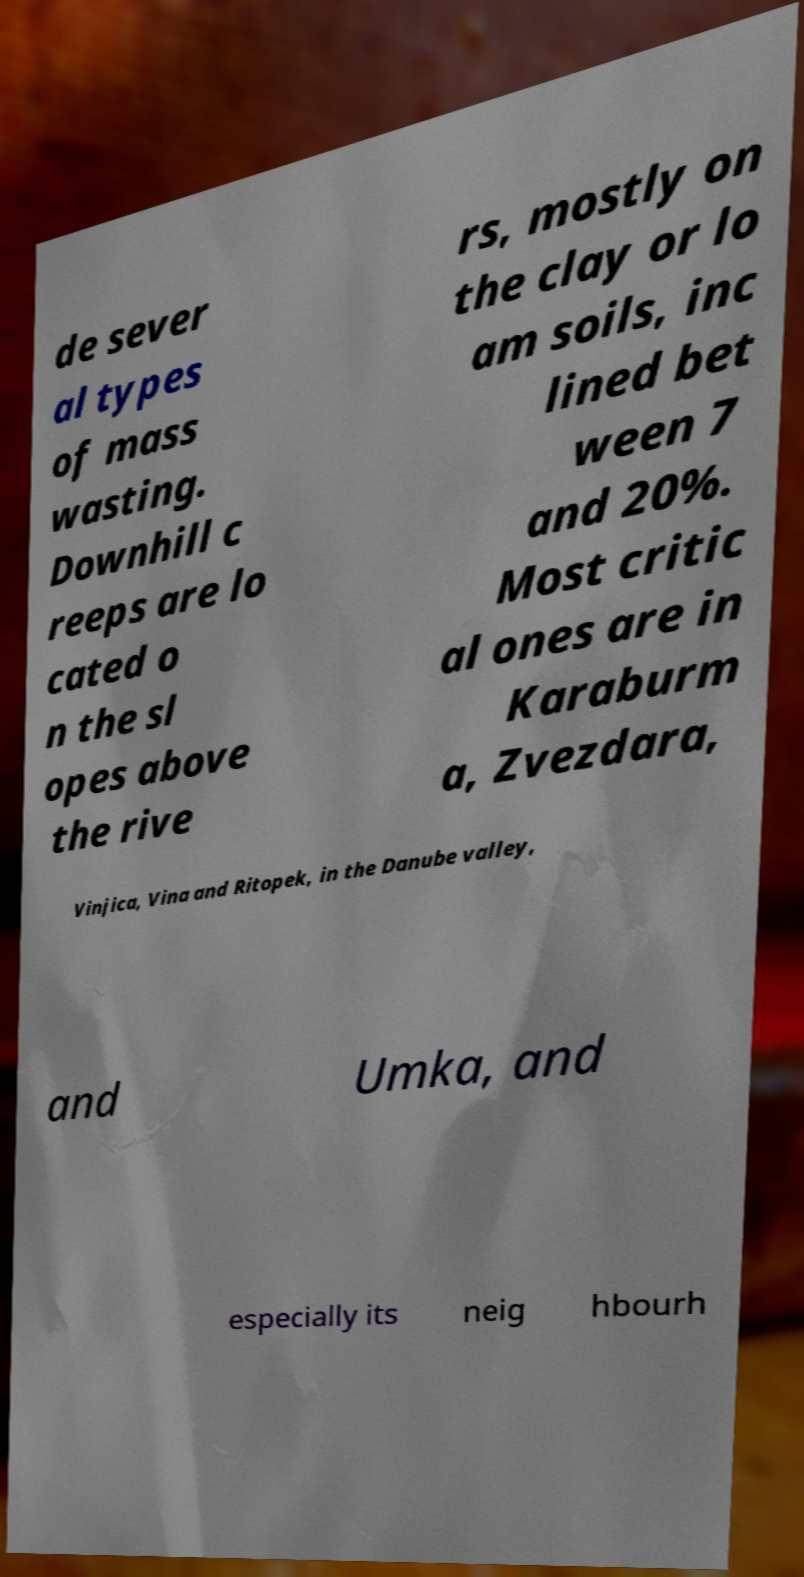Can you accurately transcribe the text from the provided image for me? de sever al types of mass wasting. Downhill c reeps are lo cated o n the sl opes above the rive rs, mostly on the clay or lo am soils, inc lined bet ween 7 and 20%. Most critic al ones are in Karaburm a, Zvezdara, Vinjica, Vina and Ritopek, in the Danube valley, and Umka, and especially its neig hbourh 